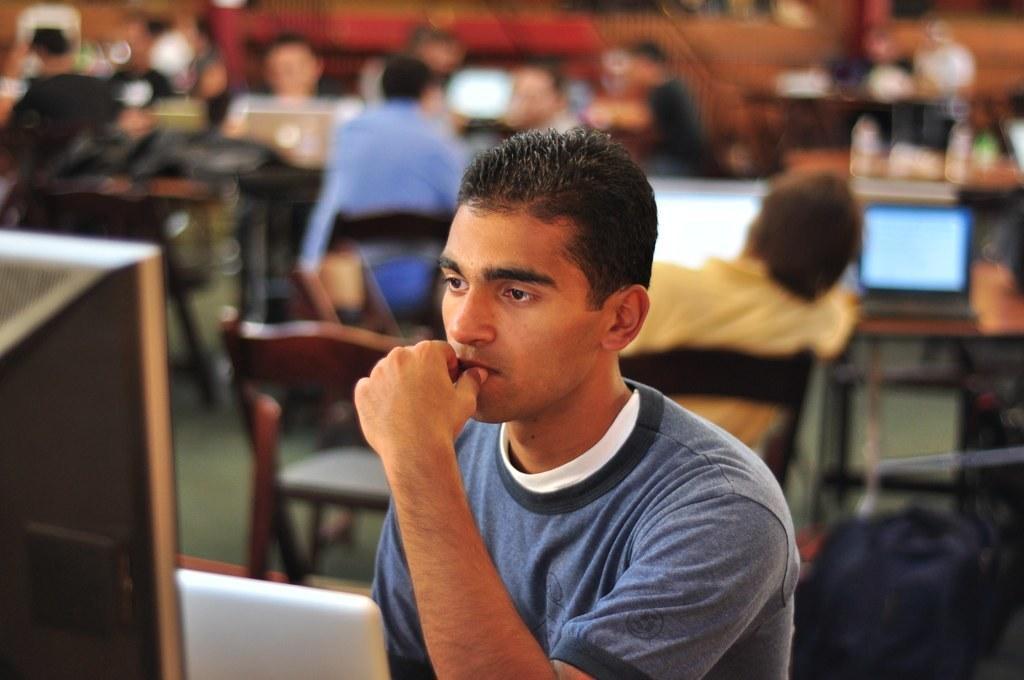In one or two sentences, can you explain what this image depicts? In this picture I can see few people seated on the chairs and I can see few monitors and laptops on the tables. 